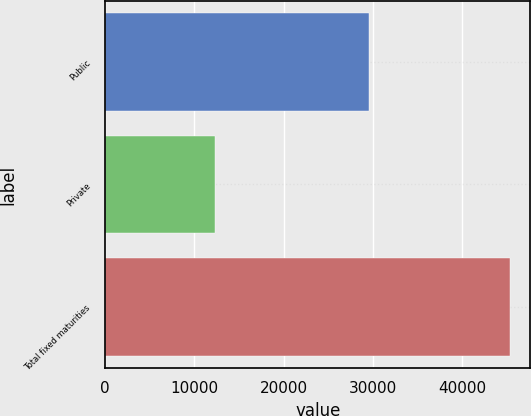<chart> <loc_0><loc_0><loc_500><loc_500><bar_chart><fcel>Public<fcel>Private<fcel>Total fixed maturities<nl><fcel>29531<fcel>12286.9<fcel>45404.5<nl></chart> 